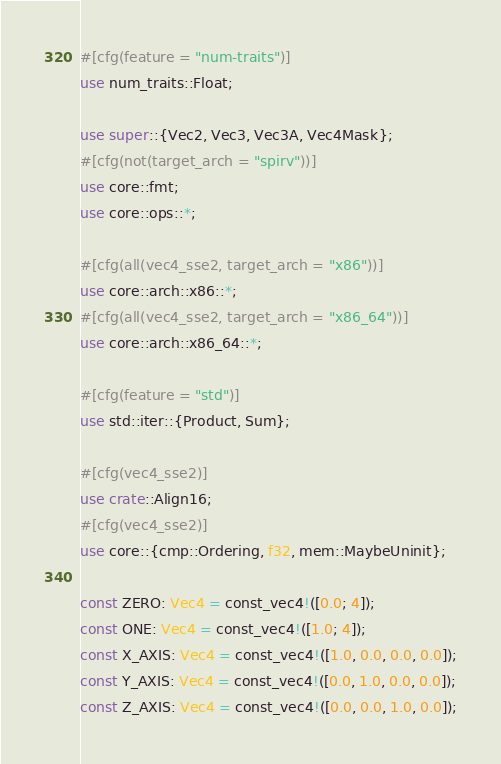<code> <loc_0><loc_0><loc_500><loc_500><_Rust_>#[cfg(feature = "num-traits")]
use num_traits::Float;

use super::{Vec2, Vec3, Vec3A, Vec4Mask};
#[cfg(not(target_arch = "spirv"))]
use core::fmt;
use core::ops::*;

#[cfg(all(vec4_sse2, target_arch = "x86"))]
use core::arch::x86::*;
#[cfg(all(vec4_sse2, target_arch = "x86_64"))]
use core::arch::x86_64::*;

#[cfg(feature = "std")]
use std::iter::{Product, Sum};

#[cfg(vec4_sse2)]
use crate::Align16;
#[cfg(vec4_sse2)]
use core::{cmp::Ordering, f32, mem::MaybeUninit};

const ZERO: Vec4 = const_vec4!([0.0; 4]);
const ONE: Vec4 = const_vec4!([1.0; 4]);
const X_AXIS: Vec4 = const_vec4!([1.0, 0.0, 0.0, 0.0]);
const Y_AXIS: Vec4 = const_vec4!([0.0, 1.0, 0.0, 0.0]);
const Z_AXIS: Vec4 = const_vec4!([0.0, 0.0, 1.0, 0.0]);</code> 